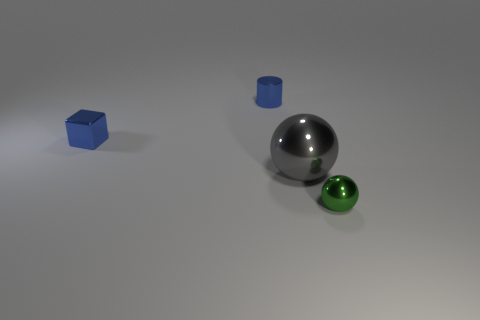Add 4 small cylinders. How many objects exist? 8 Subtract all cubes. How many objects are left? 3 Subtract 0 cyan balls. How many objects are left? 4 Subtract all green metal balls. Subtract all gray metal things. How many objects are left? 2 Add 2 blue objects. How many blue objects are left? 4 Add 1 large objects. How many large objects exist? 2 